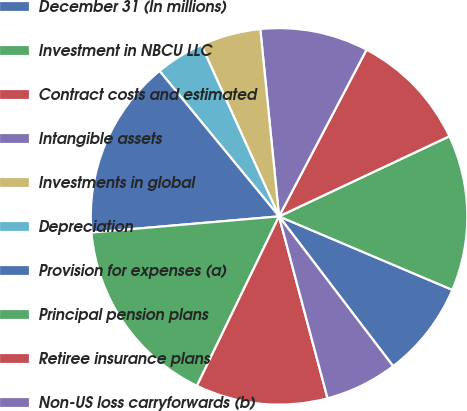Convert chart. <chart><loc_0><loc_0><loc_500><loc_500><pie_chart><fcel>December 31 (In millions)<fcel>Investment in NBCU LLC<fcel>Contract costs and estimated<fcel>Intangible assets<fcel>Investments in global<fcel>Depreciation<fcel>Provision for expenses (a)<fcel>Principal pension plans<fcel>Retiree insurance plans<fcel>Non-US loss carryforwards (b)<nl><fcel>8.26%<fcel>13.38%<fcel>10.31%<fcel>9.28%<fcel>5.19%<fcel>4.17%<fcel>15.42%<fcel>16.45%<fcel>11.33%<fcel>6.21%<nl></chart> 